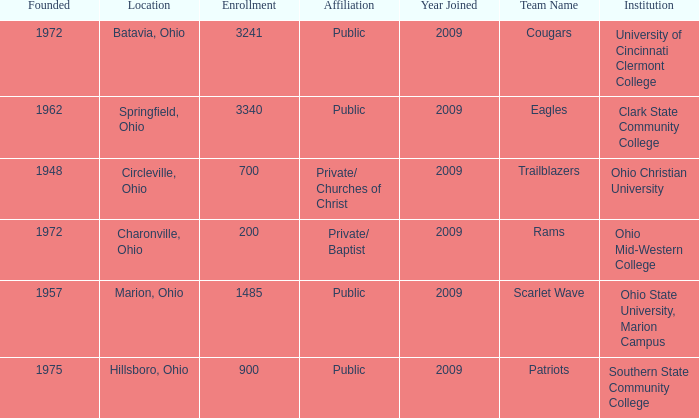What is the institution that was located is circleville, ohio? Ohio Christian University. 